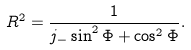Convert formula to latex. <formula><loc_0><loc_0><loc_500><loc_500>R ^ { 2 } = \frac { 1 } { j _ { - } \sin ^ { 2 } \Phi + \cos ^ { 2 } \Phi } .</formula> 